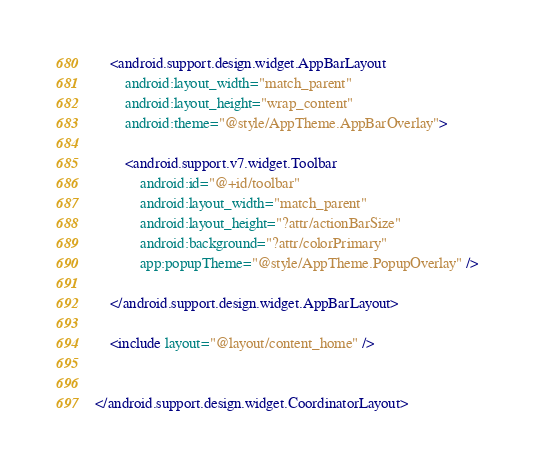<code> <loc_0><loc_0><loc_500><loc_500><_XML_>
    <android.support.design.widget.AppBarLayout
        android:layout_width="match_parent"
        android:layout_height="wrap_content"
        android:theme="@style/AppTheme.AppBarOverlay">

        <android.support.v7.widget.Toolbar
            android:id="@+id/toolbar"
            android:layout_width="match_parent"
            android:layout_height="?attr/actionBarSize"
            android:background="?attr/colorPrimary"
            app:popupTheme="@style/AppTheme.PopupOverlay" />

    </android.support.design.widget.AppBarLayout>

    <include layout="@layout/content_home" />


</android.support.design.widget.CoordinatorLayout></code> 